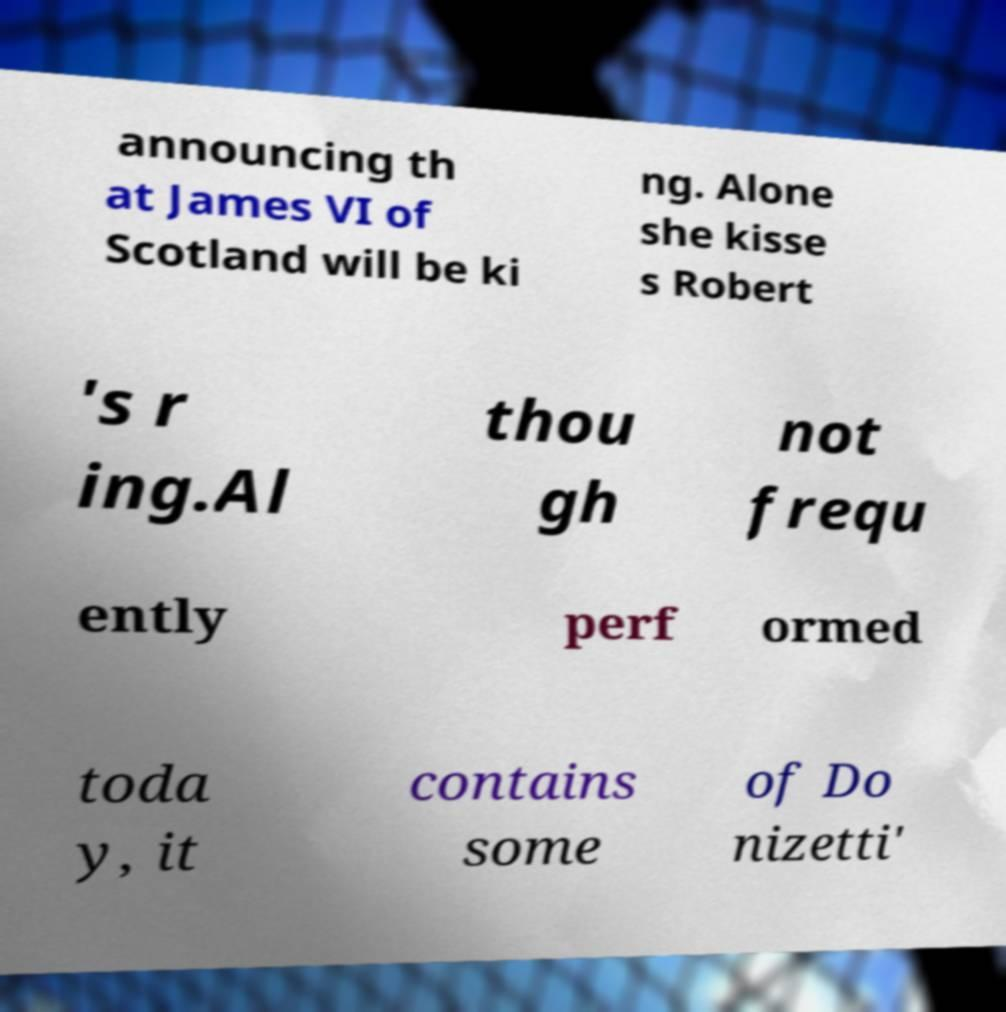Could you extract and type out the text from this image? announcing th at James VI of Scotland will be ki ng. Alone she kisse s Robert 's r ing.Al thou gh not frequ ently perf ormed toda y, it contains some of Do nizetti' 